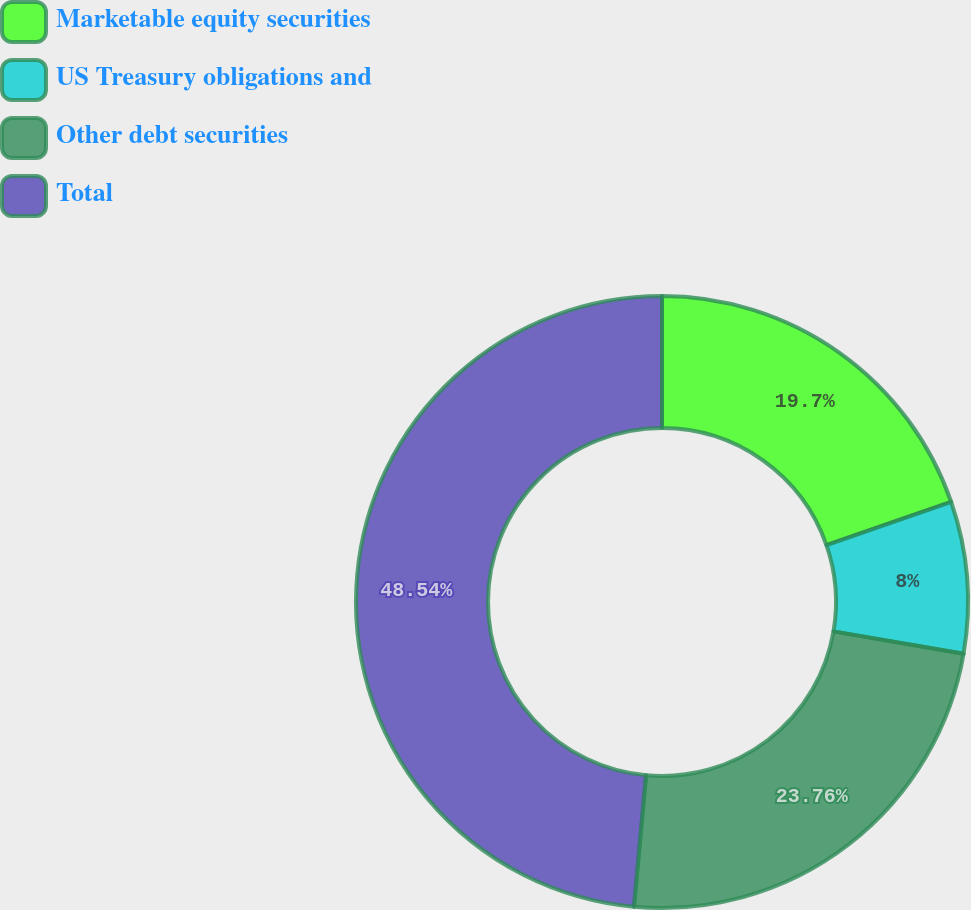<chart> <loc_0><loc_0><loc_500><loc_500><pie_chart><fcel>Marketable equity securities<fcel>US Treasury obligations and<fcel>Other debt securities<fcel>Total<nl><fcel>19.7%<fcel>8.0%<fcel>23.76%<fcel>48.54%<nl></chart> 